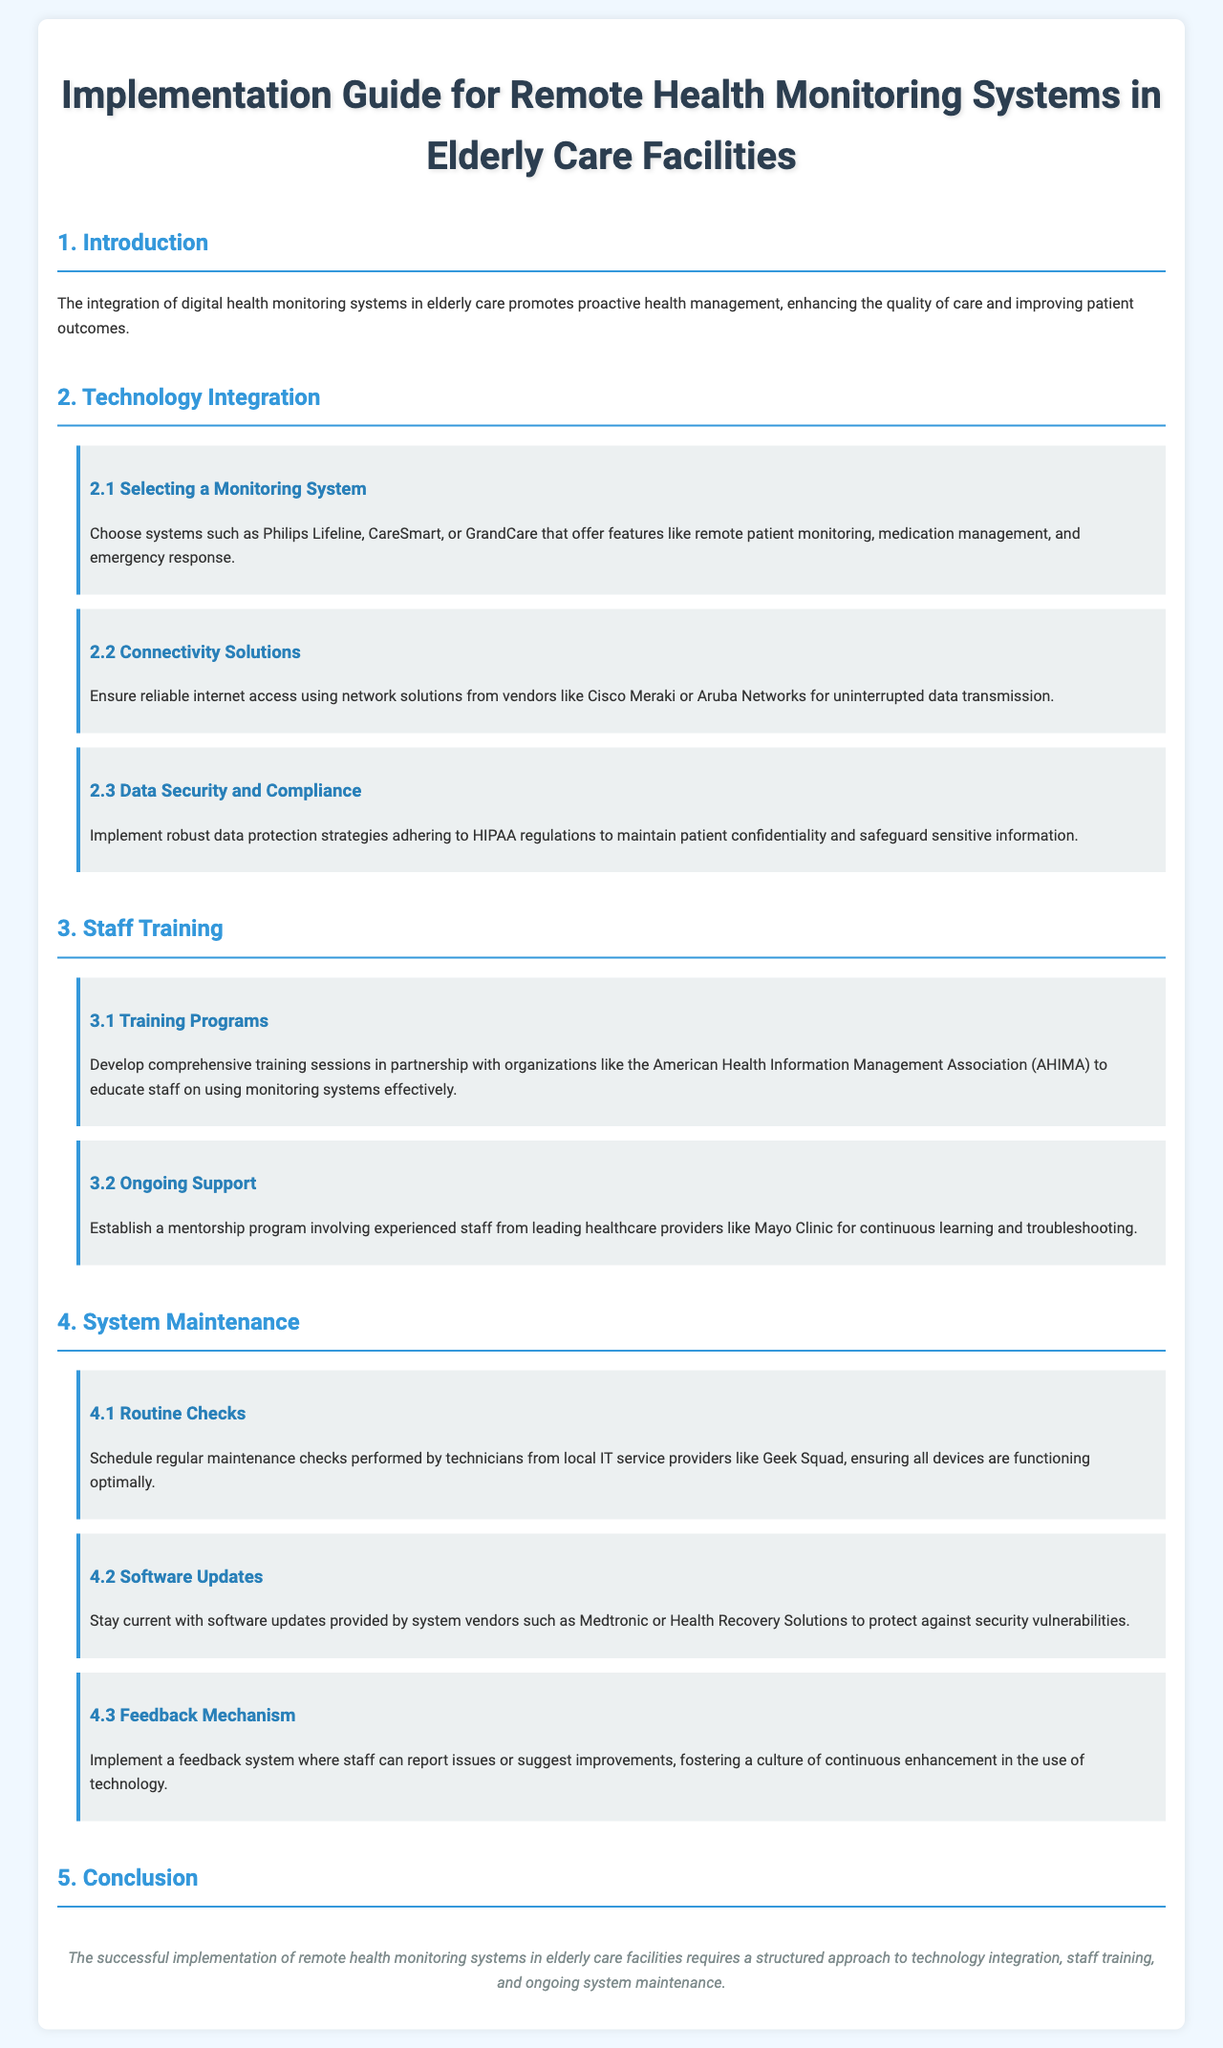what is the title of the document? The title of the document is presented prominently at the top of the rendered document.
Answer: Implementation Guide for Remote Health Monitoring Systems in Elderly Care Facilities who are the suggested vendors for connectivity solutions? The document lists vendors under the section on connectivity solutions.
Answer: Cisco Meraki or Aruba Networks what is a recommended monitoring system mentioned? The document provides examples of monitoring systems in the technology integration section.
Answer: Philips Lifeline what organization should partner for training programs? The document specifies an organization associated with staff training in the relevant section.
Answer: American Health Information Management Association (AHIMA) which website should be checked for software updates? The document identifies vendors providing software updates for system maintenance.
Answer: Medtronic or Health Recovery Solutions how often should routine checks be performed? The document implies a frequency for maintenance checks but does not specify exact timing.
Answer: Regularly what is recommended as part of the ongoing support strategy? This question asks for the type of support established in the staff training section.
Answer: Mentorship program what is the main purpose of implementing remote health monitoring systems? The introduction clarifies the focus of integrating these systems.
Answer: Proactive health management 